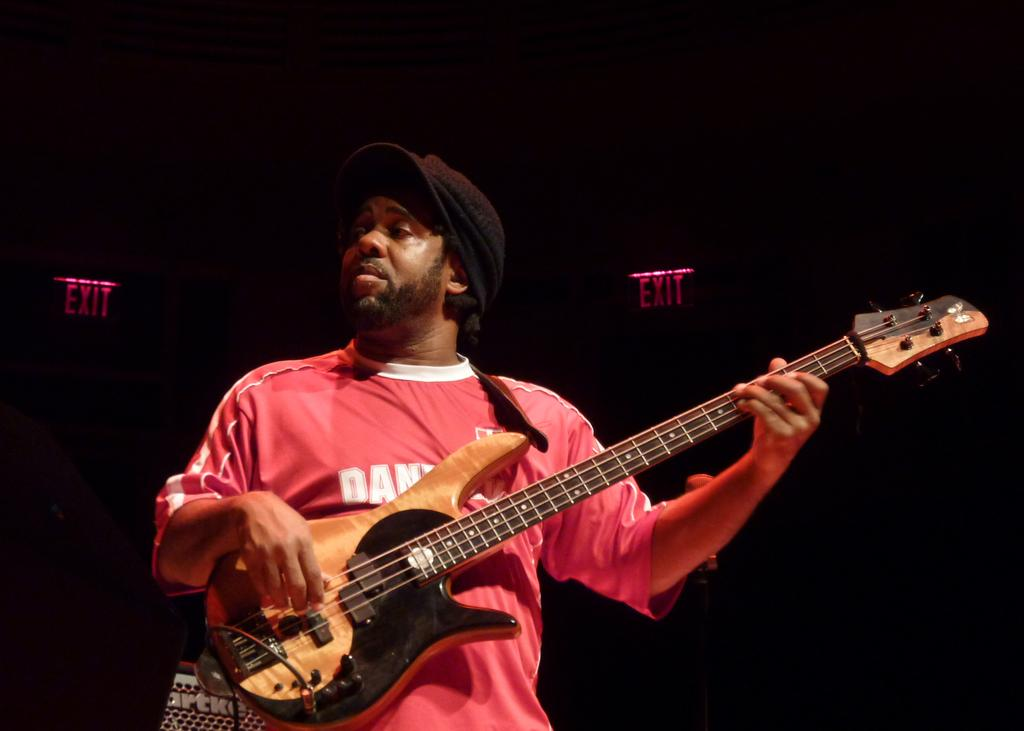Who is in the image? There is a man in the image. What is the man wearing? The man is wearing a red shirt. What is the man holding in the image? The man is holding a guitar. What is the man doing with the guitar? The man is playing the guitar. What can be seen in the background of the image? There is a board in the background of the image. What is written on the board? The board has the word "exit" written on it. What type of wire is the man using to play the guitar in the image? There is no wire mentioned or visible in the image; the man is playing the guitar without any visible wires. 